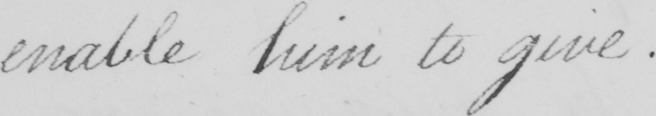What does this handwritten line say? enable him to give . 